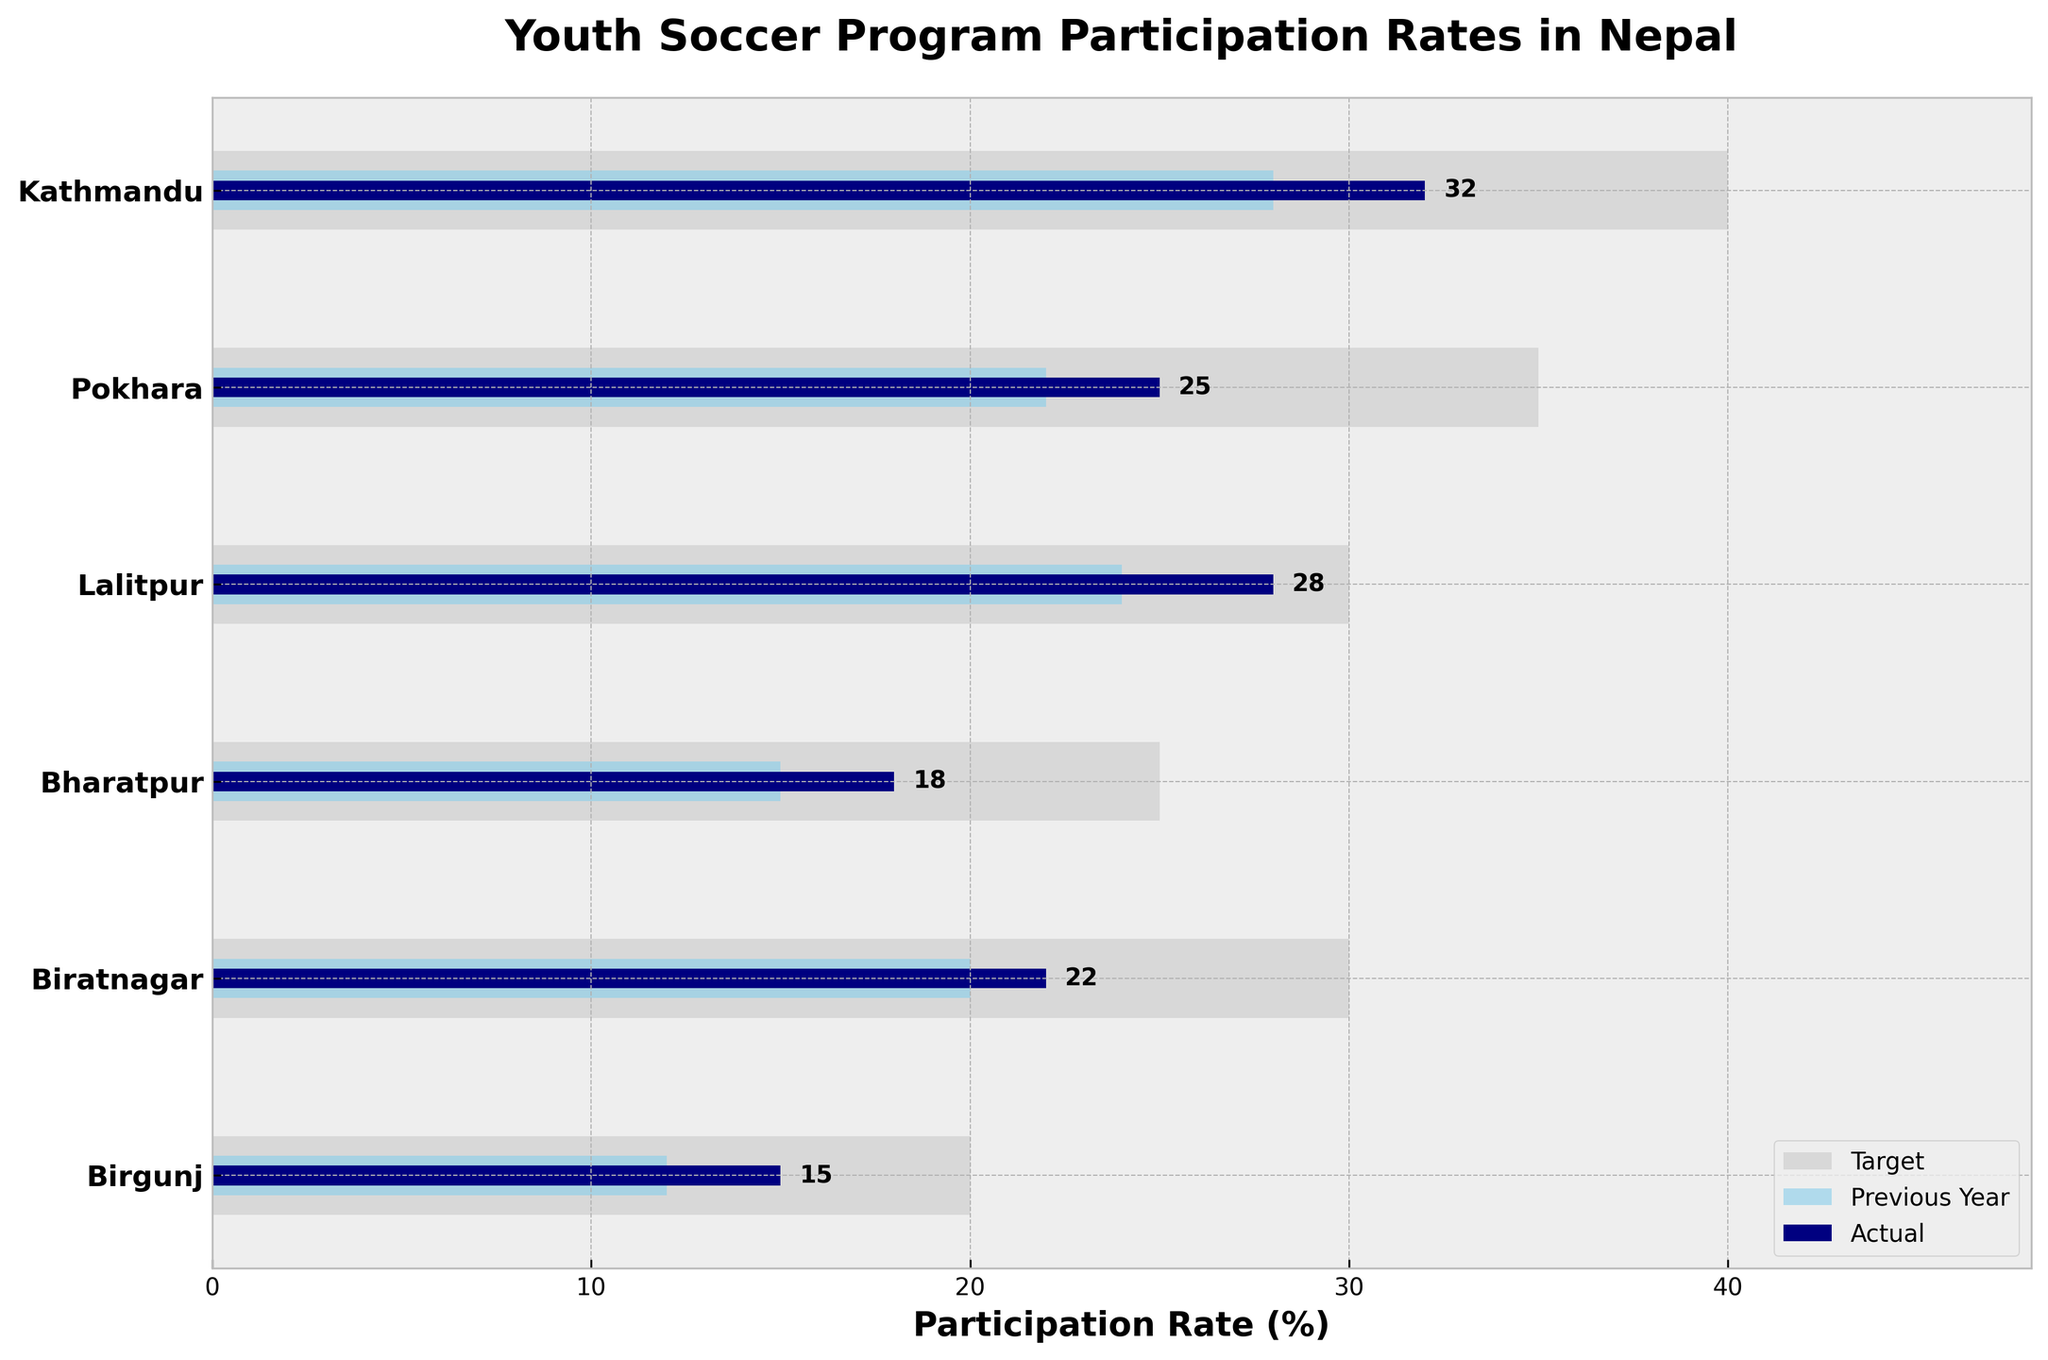What's the title of the figure? The title can be found at the top of the figure, which gives an overview of what the chart is about.
Answer: Youth Soccer Program Participation Rates in Nepal How many cities are represented in the chart? By counting the number of y-axis labels, which each represent a different city.
Answer: 6 Which city has the highest actual participation rate? Compare the actual participation rate bars across all cities and identify the tallest one.
Answer: Kathmandu Is the actual participation rate of Bharatpur higher or lower than its target? Compare the length of Bharatpur's actual participation rate bar with its target bar. The actual bar is shorter, indicating a lower rate.
Answer: Lower What is the difference between the target and actual participation rates in Birgunj? Subtract the actual participation rate of Birgunj from the target rate (20 - 15).
Answer: 5% How does Lalitpur’s participation rate last year compare to its actual rate this year? Compare the "Previous Year" bar and the "Actual" bar for Lalitpur. The previous year bar is shorter, indicating an increase.
Answer: Higher Which city has the largest gap between its target and actual participation rates? Calculate the differences for each city and compare. Biratnagar has the largest gap (30 - 22 = 8).
Answer: Biratnagar What's the average actual participation rate across all cities? Sum the actual participation rates: (32 + 25 + 28 + 18 + 22 + 15) and divide by the number of cities (6). (140 / 6 = 23.33).
Answer: 23.33% How does Kathmandu's previous year's participation rate compare to Bharatpur’s actual rate? Compare the previous year's bar for Kathmandu (28) with the actual bar for Bharatpur (18). Kathmandu's previous year's rate is higher.
Answer: Higher Is the previous year’s participation rate for any city higher than its target rate for this year? Compare the "Previous Year" bars with the "Target" bars for all cities. None of the "Previous Year" rates exceed the "Target" rates.
Answer: No 